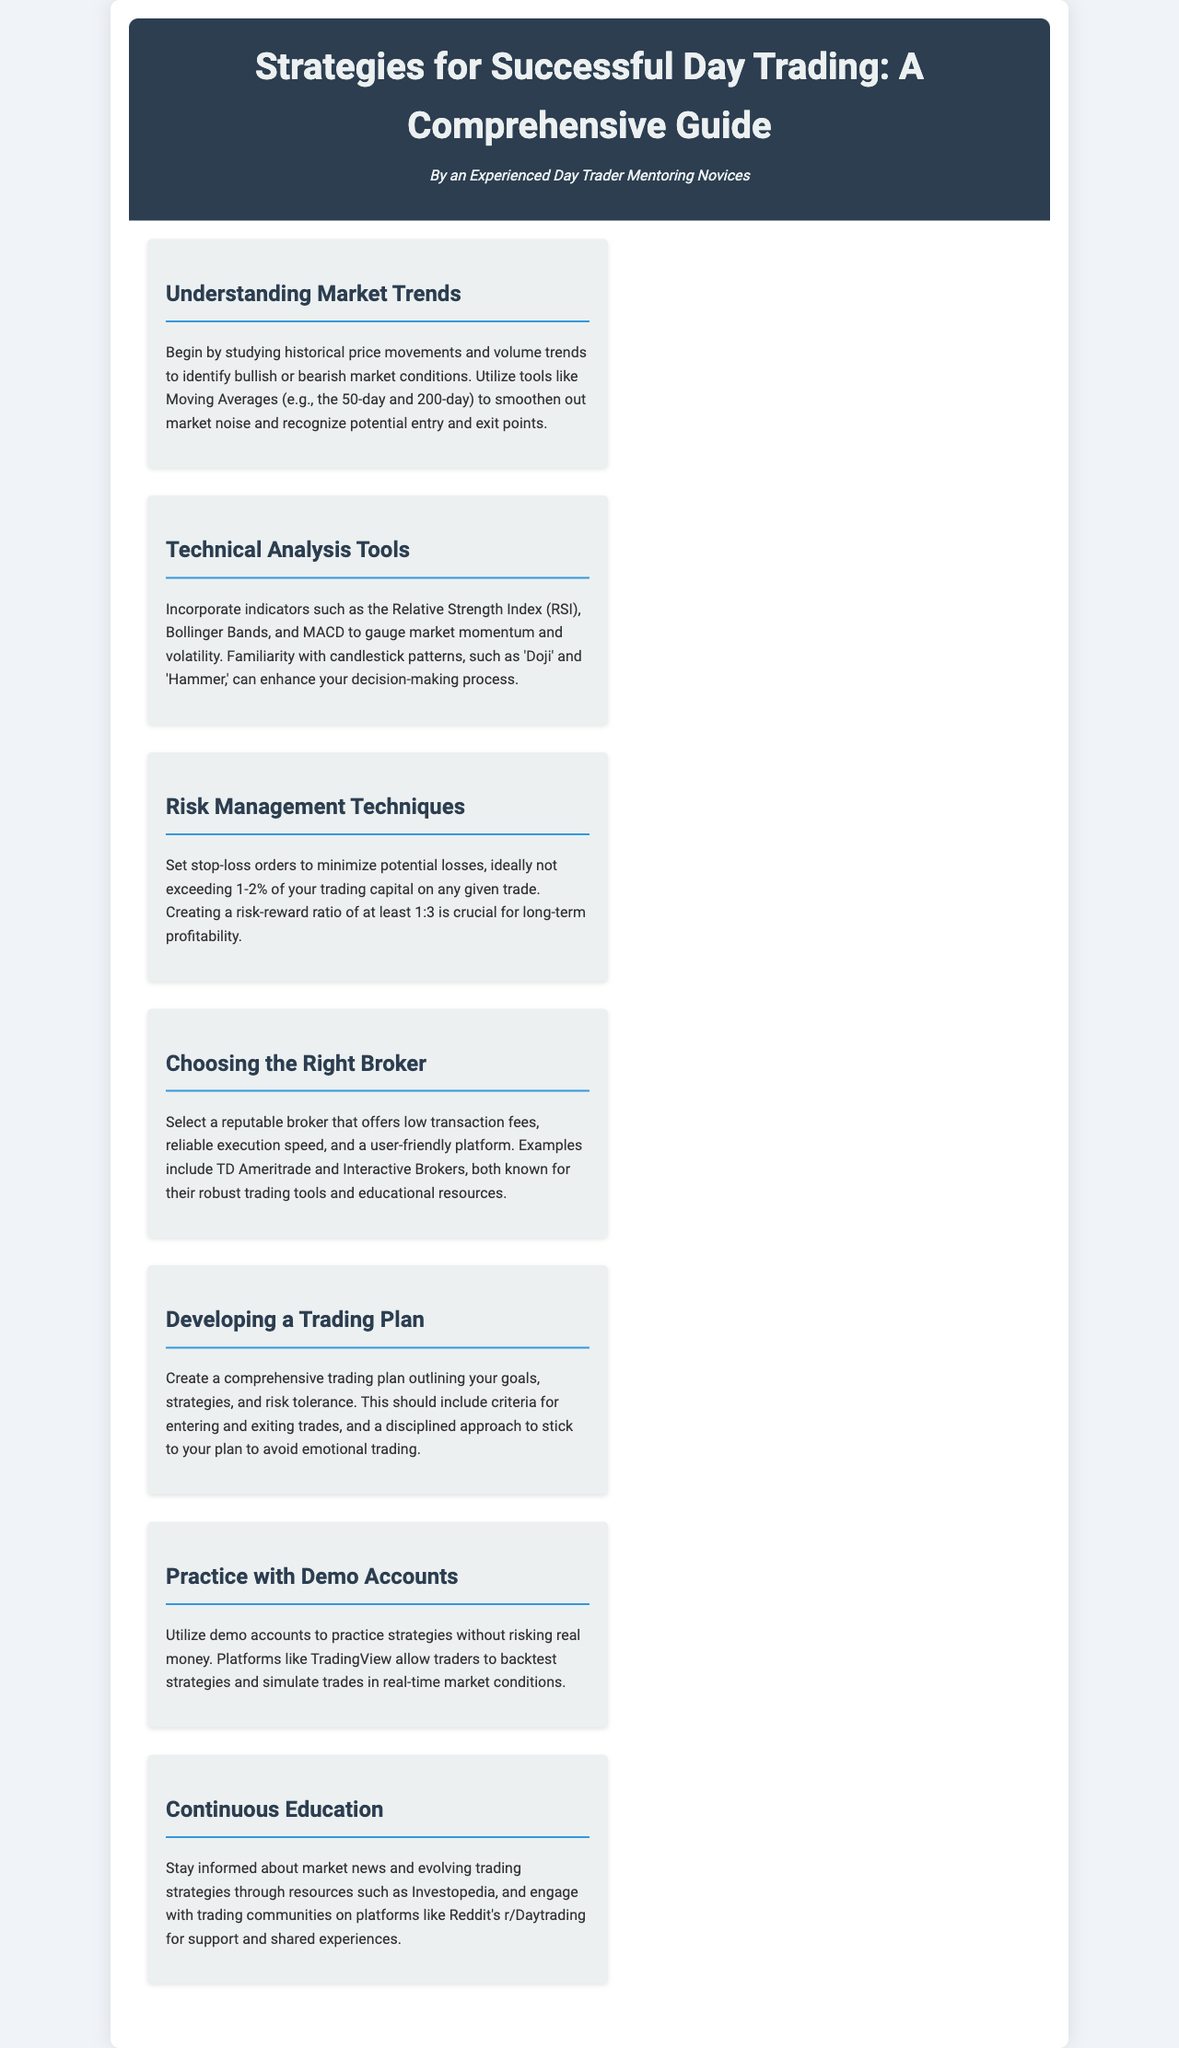What is the main focus of the guide? The guide focuses on day trading strategies for successful trading, providing insights and techniques.
Answer: day trading strategies What percentage of trading capital should be risked on a single trade? The document specifies that the risk should ideally not exceed 1-2% of trading capital for any given trade.
Answer: 1-2% Name a technical analysis tool mentioned in the document. The document lists several tools, among which the Relative Strength Index (RSI) is one of the key indicators for market analysis.
Answer: Relative Strength Index (RSI) What should be included in a trading plan? The trading plan should outline goals, strategies, and risk tolerance, including criteria for entering and exiting trades.
Answer: goals, strategies, risk tolerance Which resources are recommended for continuous education? The document suggests resources like Investopedia and community engagement through platforms like Reddit's r/Daytrading for ongoing education and support.
Answer: Investopedia, Reddit's r/Daytrading What is a crucial aspect of risk management? Creating a risk-reward ratio of at least 1:3 is emphasized as crucial for long-term profitability in trading.
Answer: risk-reward ratio of at least 1:3 What is the benefit of using demo accounts? The document explains that demo accounts allow traders to practice strategies without risking real money, simulating trades in real-time market conditions.
Answer: practice strategies without risking real money What is one example of a reputable broker? The document mentions TD Ameritrade as an example of a reputable broker known for trading tools and educational resources.
Answer: TD Ameritrade 